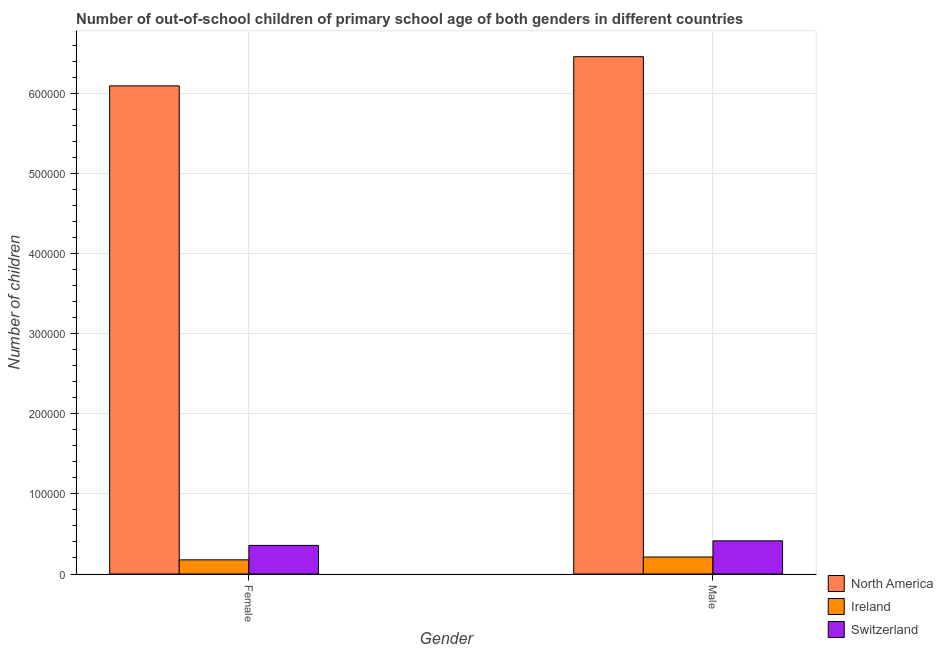How many different coloured bars are there?
Your answer should be compact. 3. How many groups of bars are there?
Keep it short and to the point. 2. Are the number of bars on each tick of the X-axis equal?
Make the answer very short. Yes. How many bars are there on the 1st tick from the right?
Provide a succinct answer. 3. What is the label of the 2nd group of bars from the left?
Ensure brevity in your answer.  Male. What is the number of female out-of-school students in North America?
Offer a terse response. 6.09e+05. Across all countries, what is the maximum number of female out-of-school students?
Keep it short and to the point. 6.09e+05. Across all countries, what is the minimum number of female out-of-school students?
Your response must be concise. 1.77e+04. In which country was the number of male out-of-school students maximum?
Provide a succinct answer. North America. In which country was the number of female out-of-school students minimum?
Provide a short and direct response. Ireland. What is the total number of male out-of-school students in the graph?
Offer a very short reply. 7.08e+05. What is the difference between the number of male out-of-school students in Ireland and that in Switzerland?
Your answer should be compact. -2.02e+04. What is the difference between the number of male out-of-school students in North America and the number of female out-of-school students in Ireland?
Give a very brief answer. 6.28e+05. What is the average number of male out-of-school students per country?
Keep it short and to the point. 2.36e+05. What is the difference between the number of male out-of-school students and number of female out-of-school students in Ireland?
Your response must be concise. 3533. What is the ratio of the number of male out-of-school students in Switzerland to that in North America?
Give a very brief answer. 0.06. What does the 3rd bar from the left in Female represents?
Give a very brief answer. Switzerland. What does the 2nd bar from the right in Male represents?
Your response must be concise. Ireland. How many countries are there in the graph?
Provide a short and direct response. 3. Does the graph contain grids?
Give a very brief answer. Yes. Where does the legend appear in the graph?
Give a very brief answer. Bottom right. What is the title of the graph?
Offer a terse response. Number of out-of-school children of primary school age of both genders in different countries. What is the label or title of the Y-axis?
Your answer should be compact. Number of children. What is the Number of children in North America in Female?
Your answer should be compact. 6.09e+05. What is the Number of children of Ireland in Female?
Your answer should be compact. 1.77e+04. What is the Number of children in Switzerland in Female?
Provide a succinct answer. 3.57e+04. What is the Number of children in North America in Male?
Offer a terse response. 6.45e+05. What is the Number of children in Ireland in Male?
Provide a succinct answer. 2.12e+04. What is the Number of children in Switzerland in Male?
Provide a succinct answer. 4.14e+04. Across all Gender, what is the maximum Number of children of North America?
Ensure brevity in your answer.  6.45e+05. Across all Gender, what is the maximum Number of children of Ireland?
Offer a very short reply. 2.12e+04. Across all Gender, what is the maximum Number of children in Switzerland?
Your answer should be very brief. 4.14e+04. Across all Gender, what is the minimum Number of children in North America?
Your answer should be very brief. 6.09e+05. Across all Gender, what is the minimum Number of children in Ireland?
Your answer should be compact. 1.77e+04. Across all Gender, what is the minimum Number of children of Switzerland?
Ensure brevity in your answer.  3.57e+04. What is the total Number of children in North America in the graph?
Provide a short and direct response. 1.25e+06. What is the total Number of children of Ireland in the graph?
Ensure brevity in your answer.  3.89e+04. What is the total Number of children in Switzerland in the graph?
Provide a short and direct response. 7.71e+04. What is the difference between the Number of children in North America in Female and that in Male?
Offer a terse response. -3.64e+04. What is the difference between the Number of children in Ireland in Female and that in Male?
Your response must be concise. -3533. What is the difference between the Number of children in Switzerland in Female and that in Male?
Give a very brief answer. -5683. What is the difference between the Number of children of North America in Female and the Number of children of Ireland in Male?
Give a very brief answer. 5.88e+05. What is the difference between the Number of children in North America in Female and the Number of children in Switzerland in Male?
Your answer should be compact. 5.68e+05. What is the difference between the Number of children of Ireland in Female and the Number of children of Switzerland in Male?
Make the answer very short. -2.37e+04. What is the average Number of children of North America per Gender?
Your answer should be compact. 6.27e+05. What is the average Number of children of Ireland per Gender?
Your response must be concise. 1.94e+04. What is the average Number of children of Switzerland per Gender?
Your answer should be compact. 3.85e+04. What is the difference between the Number of children in North America and Number of children in Ireland in Female?
Provide a short and direct response. 5.91e+05. What is the difference between the Number of children in North America and Number of children in Switzerland in Female?
Offer a very short reply. 5.73e+05. What is the difference between the Number of children in Ireland and Number of children in Switzerland in Female?
Ensure brevity in your answer.  -1.80e+04. What is the difference between the Number of children in North America and Number of children in Ireland in Male?
Your response must be concise. 6.24e+05. What is the difference between the Number of children of North America and Number of children of Switzerland in Male?
Make the answer very short. 6.04e+05. What is the difference between the Number of children in Ireland and Number of children in Switzerland in Male?
Provide a short and direct response. -2.02e+04. What is the ratio of the Number of children in North America in Female to that in Male?
Make the answer very short. 0.94. What is the ratio of the Number of children of Ireland in Female to that in Male?
Provide a succinct answer. 0.83. What is the ratio of the Number of children in Switzerland in Female to that in Male?
Provide a short and direct response. 0.86. What is the difference between the highest and the second highest Number of children of North America?
Keep it short and to the point. 3.64e+04. What is the difference between the highest and the second highest Number of children of Ireland?
Your response must be concise. 3533. What is the difference between the highest and the second highest Number of children in Switzerland?
Provide a succinct answer. 5683. What is the difference between the highest and the lowest Number of children in North America?
Ensure brevity in your answer.  3.64e+04. What is the difference between the highest and the lowest Number of children in Ireland?
Provide a short and direct response. 3533. What is the difference between the highest and the lowest Number of children of Switzerland?
Offer a terse response. 5683. 